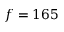<formula> <loc_0><loc_0><loc_500><loc_500>f = 1 6 5</formula> 